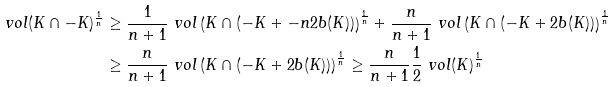Convert formula to latex. <formula><loc_0><loc_0><loc_500><loc_500>\ v o l ( K \cap - K ) ^ { \frac { 1 } { n } } & \geq \frac { 1 } { n + 1 } \ v o l \left ( K \cap ( - K + - n 2 b ( K ) ) \right ) ^ { \frac { 1 } { n } } + \frac { n } { n + 1 } \ v o l \left ( K \cap ( - K + 2 b ( K ) ) \right ) ^ { \frac { 1 } { n } } \\ & \geq \frac { n } { n + 1 } \ v o l \left ( K \cap ( - K + 2 b ( K ) ) \right ) ^ { \frac { 1 } { n } } \geq \frac { n } { n + 1 } \frac { 1 } { 2 } \ v o l ( K ) ^ { \frac { 1 } { n } }</formula> 